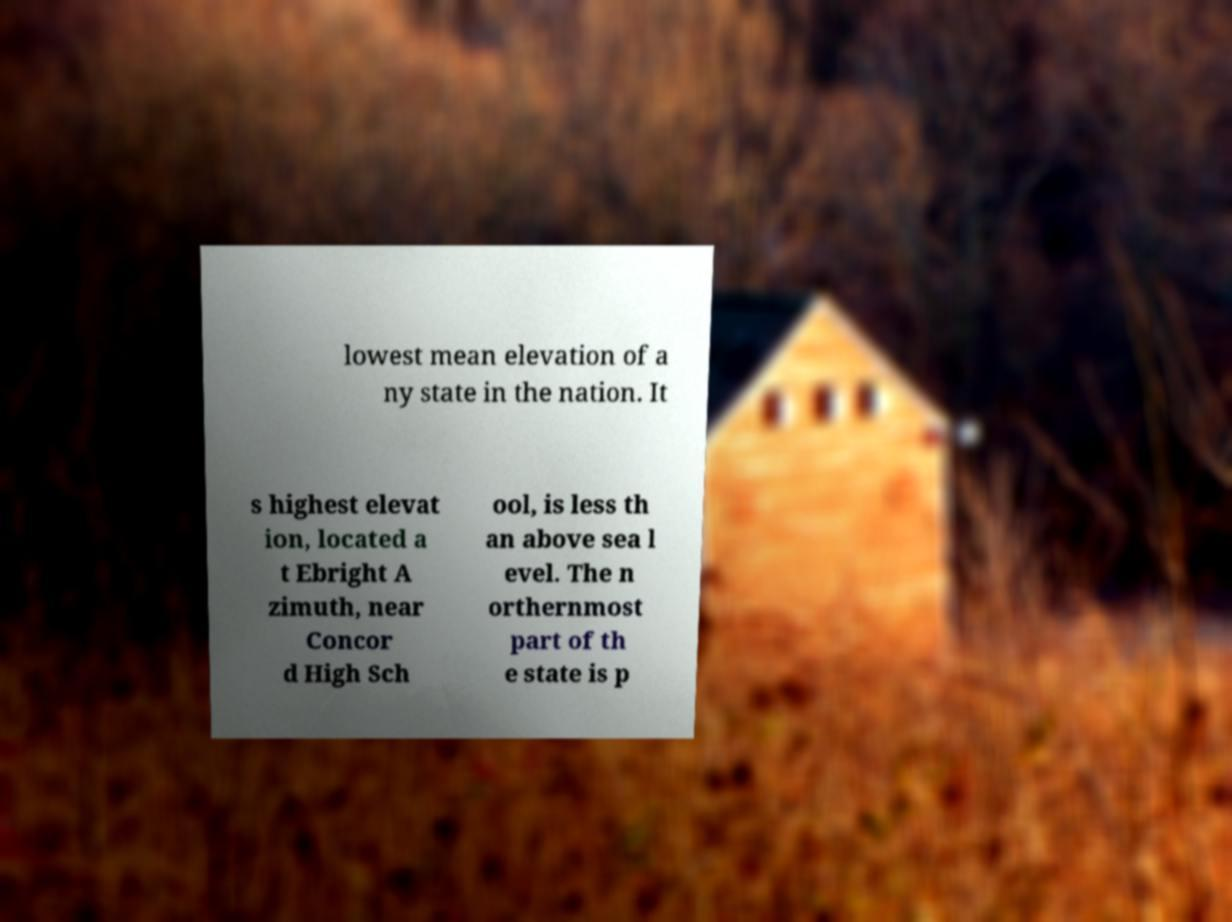What messages or text are displayed in this image? I need them in a readable, typed format. lowest mean elevation of a ny state in the nation. It s highest elevat ion, located a t Ebright A zimuth, near Concor d High Sch ool, is less th an above sea l evel. The n orthernmost part of th e state is p 